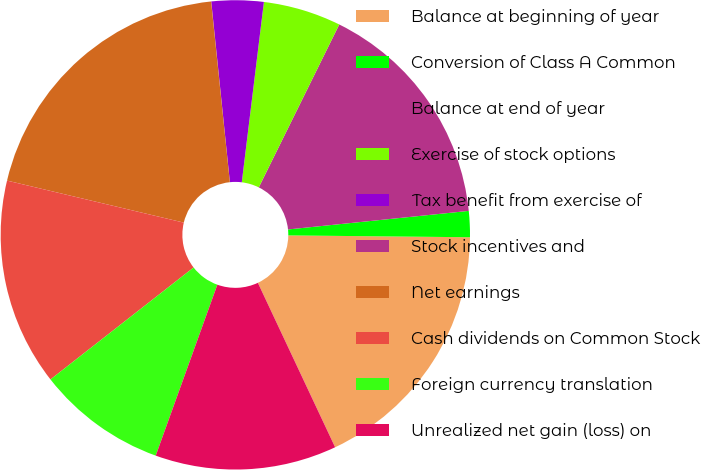Convert chart. <chart><loc_0><loc_0><loc_500><loc_500><pie_chart><fcel>Balance at beginning of year<fcel>Conversion of Class A Common<fcel>Balance at end of year<fcel>Exercise of stock options<fcel>Tax benefit from exercise of<fcel>Stock incentives and<fcel>Net earnings<fcel>Cash dividends on Common Stock<fcel>Foreign currency translation<fcel>Unrealized net gain (loss) on<nl><fcel>17.85%<fcel>1.79%<fcel>16.07%<fcel>5.36%<fcel>3.58%<fcel>0.01%<fcel>19.64%<fcel>14.28%<fcel>8.93%<fcel>12.5%<nl></chart> 